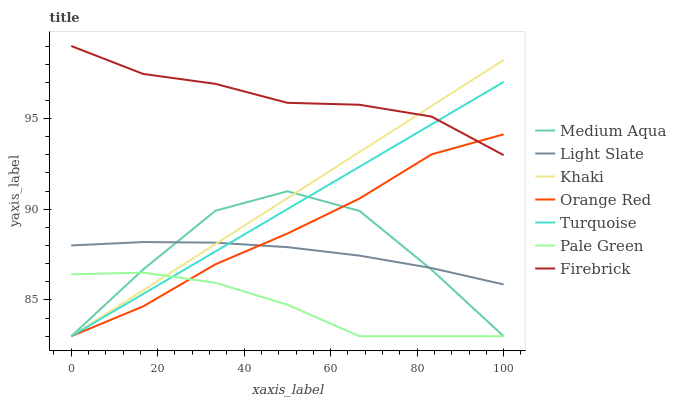Does Pale Green have the minimum area under the curve?
Answer yes or no. Yes. Does Firebrick have the maximum area under the curve?
Answer yes or no. Yes. Does Khaki have the minimum area under the curve?
Answer yes or no. No. Does Khaki have the maximum area under the curve?
Answer yes or no. No. Is Turquoise the smoothest?
Answer yes or no. Yes. Is Medium Aqua the roughest?
Answer yes or no. Yes. Is Khaki the smoothest?
Answer yes or no. No. Is Khaki the roughest?
Answer yes or no. No. Does Turquoise have the lowest value?
Answer yes or no. Yes. Does Light Slate have the lowest value?
Answer yes or no. No. Does Firebrick have the highest value?
Answer yes or no. Yes. Does Khaki have the highest value?
Answer yes or no. No. Is Pale Green less than Firebrick?
Answer yes or no. Yes. Is Firebrick greater than Light Slate?
Answer yes or no. Yes. Does Pale Green intersect Khaki?
Answer yes or no. Yes. Is Pale Green less than Khaki?
Answer yes or no. No. Is Pale Green greater than Khaki?
Answer yes or no. No. Does Pale Green intersect Firebrick?
Answer yes or no. No. 